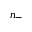Convert formula to latex. <formula><loc_0><loc_0><loc_500><loc_500>n _ { - }</formula> 